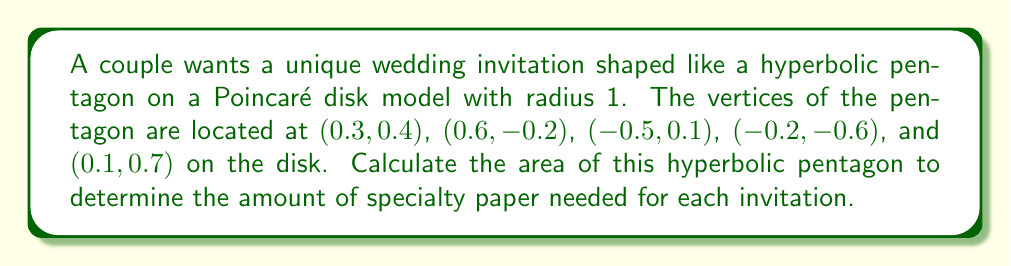Give your solution to this math problem. To calculate the area of a hyperbolic pentagon on a Poincaré disk model, we'll follow these steps:

1) In hyperbolic geometry, the area of a polygon is given by:

   $$A = (\text{sum of angles} - (n-2)\pi) \cdot R^2$$

   where $n$ is the number of sides and $R$ is the radius of curvature.

2) For the Poincaré disk model with radius 1, $R = 1$.

3) We need to calculate the angles of the pentagon. In the Poincaré disk model, we use the following formula for the angle between two geodesics intersecting at point $(x,y)$:

   $$\theta = |\arg(\frac{z_2-z}{1-\bar{z}z_2}) - \arg(\frac{z_1-z}{1-\bar{z}z_1})|$$

   where $z = x+yi$, and $z_1$ and $z_2$ are the complex representations of the adjacent vertices.

4) Calculate each angle:
   
   For vertex $(0.3, 0.4)$: $\theta_1 \approx 1.9634$
   For vertex $(0.6, -0.2)$: $\theta_2 \approx 2.1845$
   For vertex $(-0.5, 0.1)$: $\theta_3 \approx 2.3562$
   For vertex $(-0.2, -0.6)$: $\theta_4 \approx 2.0981$
   For vertex $(0.1, 0.7)$: $\theta_5 \approx 2.2453$

5) Sum of angles: $\sum \theta_i \approx 10.8475$

6) Apply the area formula:

   $$A = (10.8475 - (5-2)\pi) \cdot 1^2 \approx 1.4095$$

Therefore, the area of the hyperbolic pentagon is approximately 1.4095 square units in the Poincaré disk model.
Answer: $1.4095$ square units 